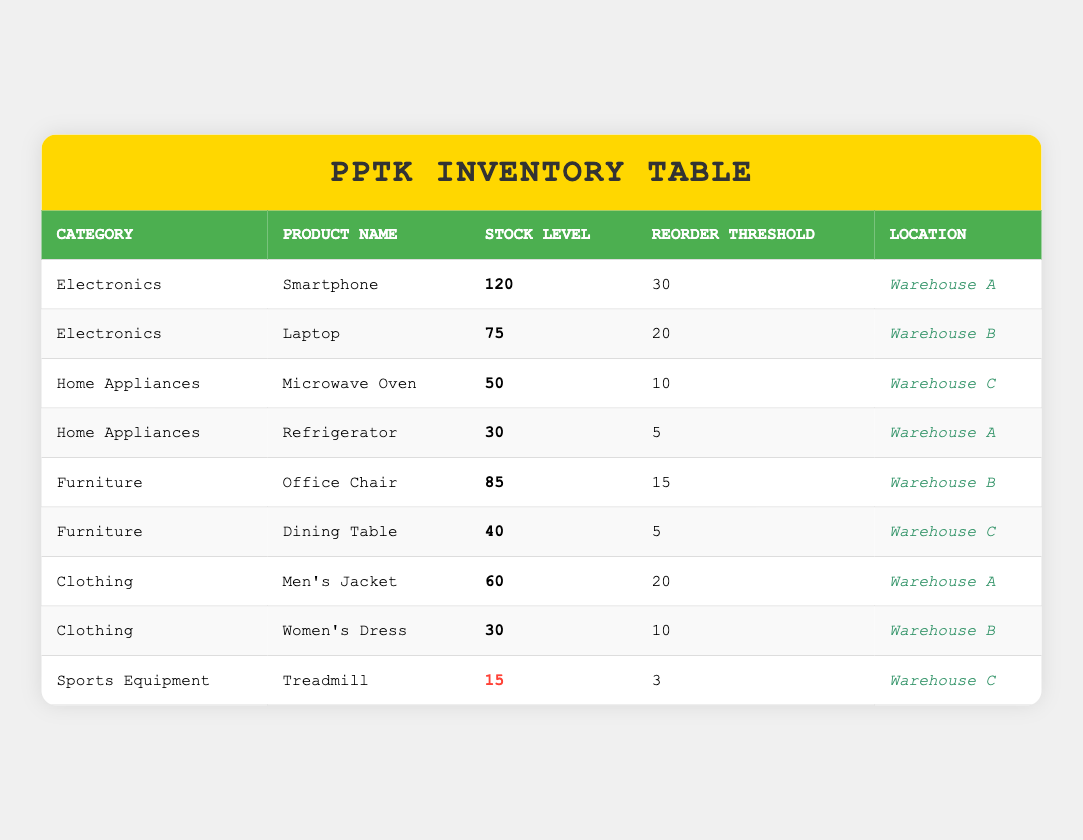What is the stock level of the Laptop? The table lists the stock level for each product. From the row corresponding to the Laptop under the Electronics category, the stock level is 75.
Answer: 75 How many products are below their reorder threshold? We need to identify products whose stock levels are below their reorder thresholds. Analyzing each row, the products below their reorder thresholds are the Refrigerator (30 < 5), Women's Dress (30 < 10), and Treadmill (15 < 3). Thus, there are three products below the threshold.
Answer: 3 What is the category of the product with the lowest stock level? The lowest stock level can be found by looking through each row. The Treadmill has the lowest stock level of 15. The Treadmill belongs to the Sports Equipment category.
Answer: Sports Equipment Which product has the highest stock level and what is its value? To find the product with the highest stock level, we check the stock levels listed: Smartphone (120), Laptop (75), Microwave Oven (50), Refrigerator (30), Office Chair (85), Dining Table (40), Men’s Jacket (60), Women's Dress (30), Treadmill (15). The Smartphone stands out with the highest stock level of 120.
Answer: Smartphone, 120 Is there a product in the Clothing category with a stock level of 40 or more? We must check the clothing products: Men's Jacket has 60 and Women's Dress has 30. Since 60 is greater than 40, there is indeed a product in this category meeting the criteria.
Answer: Yes What is the average stock level of products in the Home Appliances category? The stock levels in Home Appliances are: Microwave Oven (50) and Refrigerator (30). The sum of these stock levels is 50 + 30 = 80. There are 2 products, so the average is 80 / 2 = 40.
Answer: 40 Are there more products in the Electronics category than in Furniture category? The Electronics category has 2 products: Smartphone and Laptop, while the Furniture category also has 2 products: Office Chair and Dining Table. Since both have the same number of products, the answer is no.
Answer: No How many products have a stock level of exactly 30? We need to examine each stock level. The products with a stock level of 30 are the Refrigerator and the Women's Dress. Counting these gives us 2 products with exactly 30 stock.
Answer: 2 What is the total stock level across all categories? To find the total stock level, add each product's stock level: 120 (Smartphone) + 75 (Laptop) + 50 (Microwave) + 30 (Refrigerator) + 85 (Office Chair) + 40 (Dining Table) + 60 (Men's Jacket) + 30 (Women's Dress) + 15 (Treadmill) = 505.
Answer: 505 